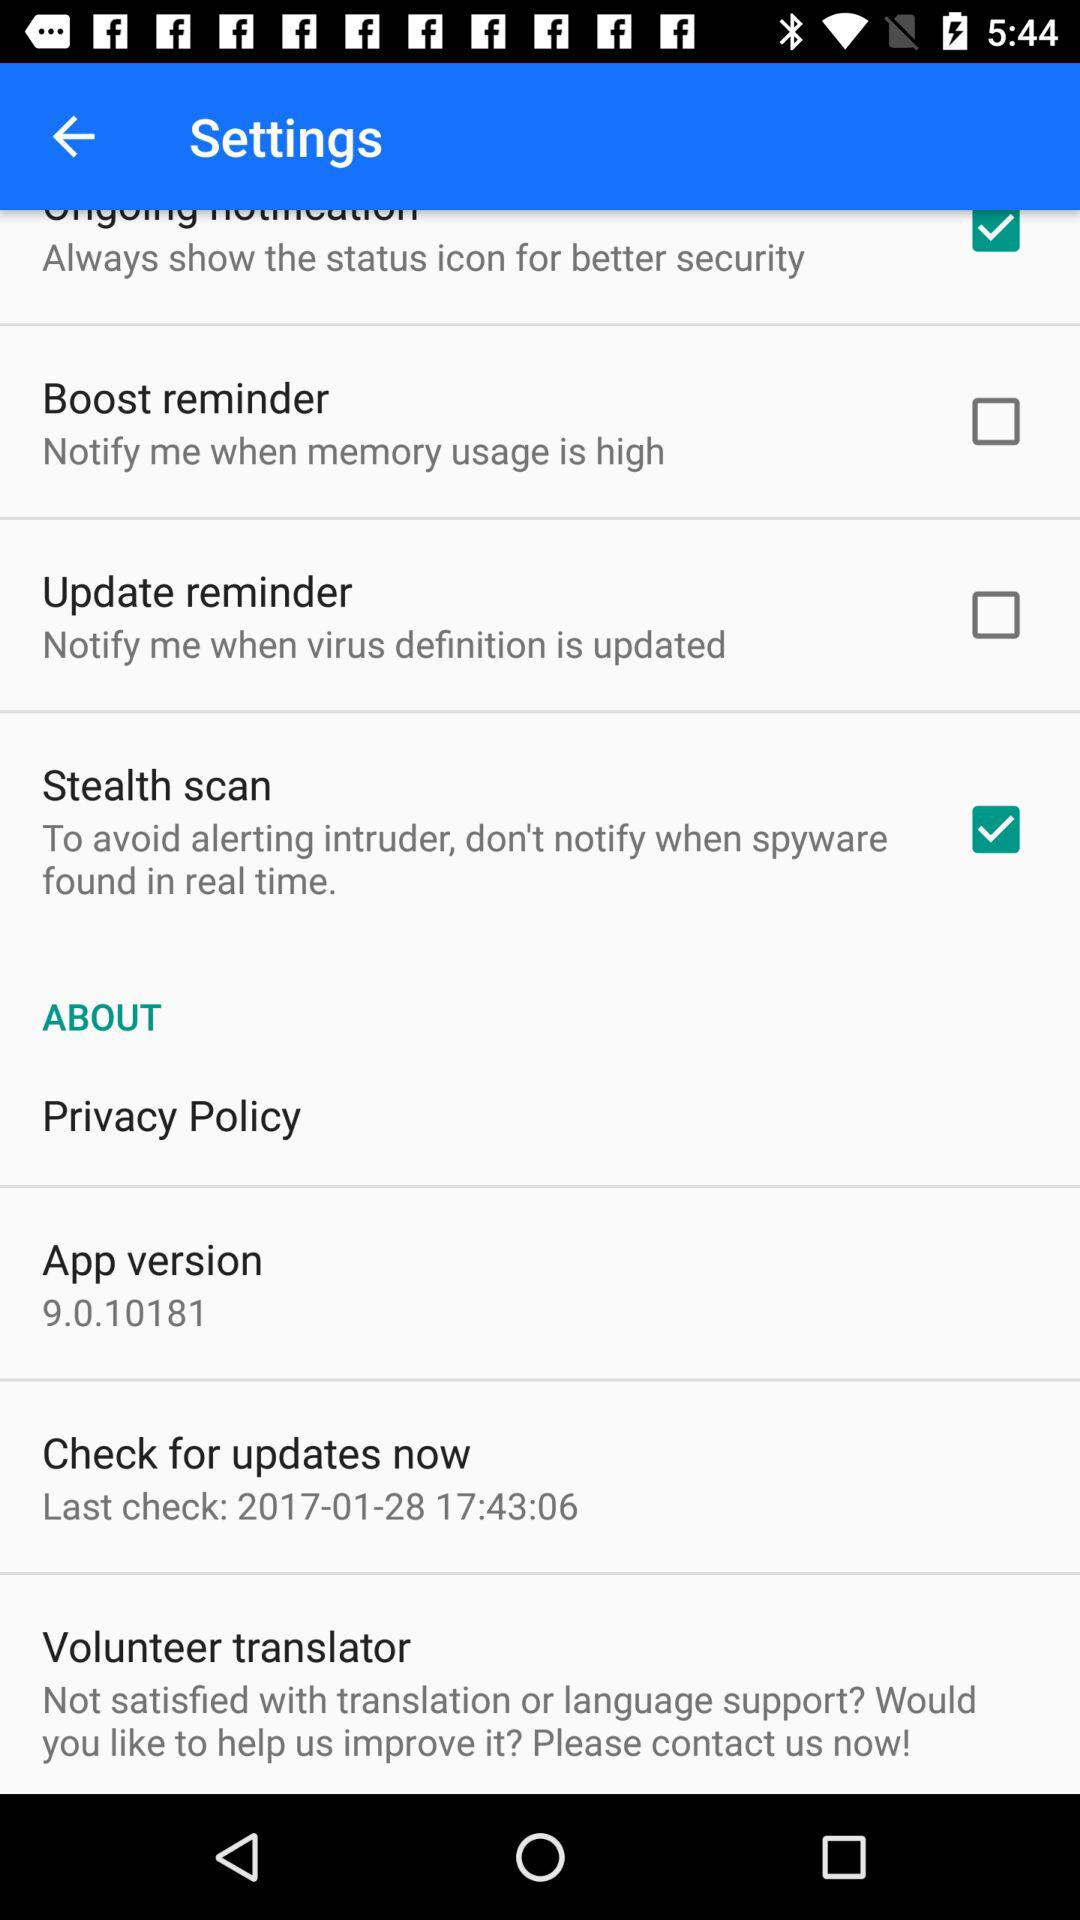What is the status of "Stealth scan"? The status of "Stealth scan" is "on". 